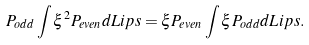Convert formula to latex. <formula><loc_0><loc_0><loc_500><loc_500>P _ { o d d } \int \xi ^ { 2 } P _ { e v e n } d L i p s = \xi P _ { e v e n } \int \xi P _ { o d d } d L i p s .</formula> 